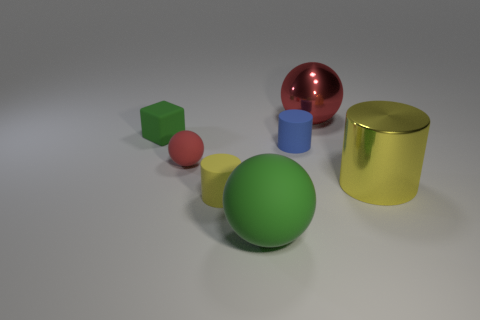What material is the large red thing that is the same shape as the tiny red rubber object?
Your response must be concise. Metal. What shape is the big metallic thing in front of the small green object?
Provide a succinct answer. Cylinder. What number of other things are the same shape as the small red matte thing?
Offer a terse response. 2. Do the tiny object that is on the right side of the tiny yellow object and the large green thing have the same material?
Provide a short and direct response. Yes. Are there an equal number of red rubber spheres that are in front of the tiny sphere and big shiny cylinders that are on the left side of the small green matte object?
Ensure brevity in your answer.  Yes. There is a green rubber object that is right of the tiny red thing; how big is it?
Offer a very short reply. Large. Is there a red sphere that has the same material as the blue cylinder?
Offer a terse response. Yes. There is a small object in front of the red rubber object; is it the same color as the large metal cylinder?
Offer a terse response. Yes. Is the number of rubber objects left of the large matte thing the same as the number of large purple matte objects?
Your answer should be very brief. No. Is there a small rubber block of the same color as the large rubber sphere?
Make the answer very short. Yes. 